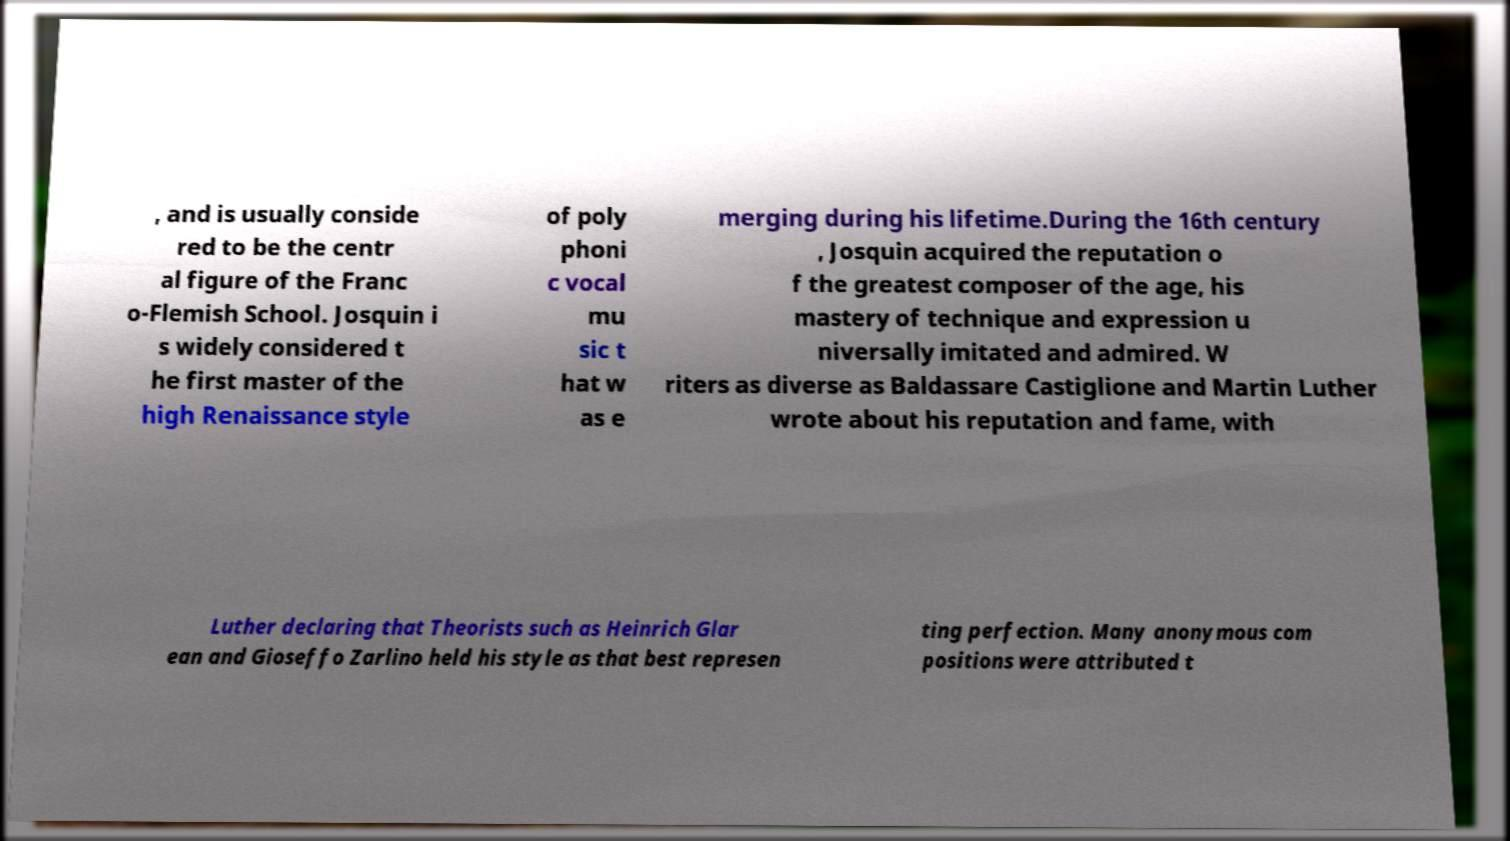Could you extract and type out the text from this image? , and is usually conside red to be the centr al figure of the Franc o-Flemish School. Josquin i s widely considered t he first master of the high Renaissance style of poly phoni c vocal mu sic t hat w as e merging during his lifetime.During the 16th century , Josquin acquired the reputation o f the greatest composer of the age, his mastery of technique and expression u niversally imitated and admired. W riters as diverse as Baldassare Castiglione and Martin Luther wrote about his reputation and fame, with Luther declaring that Theorists such as Heinrich Glar ean and Gioseffo Zarlino held his style as that best represen ting perfection. Many anonymous com positions were attributed t 